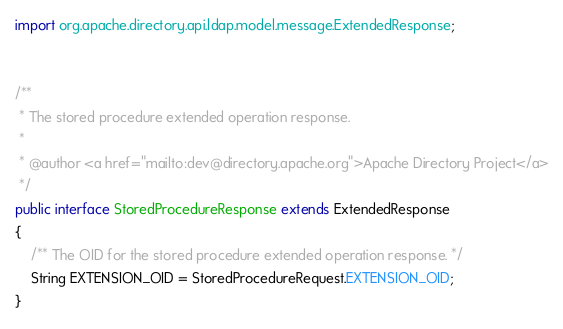<code> <loc_0><loc_0><loc_500><loc_500><_Java_>import org.apache.directory.api.ldap.model.message.ExtendedResponse;


/**
 * The stored procedure extended operation response.
 *
 * @author <a href="mailto:dev@directory.apache.org">Apache Directory Project</a>
 */
public interface StoredProcedureResponse extends ExtendedResponse
{
    /** The OID for the stored procedure extended operation response. */
    String EXTENSION_OID = StoredProcedureRequest.EXTENSION_OID;
}
</code> 